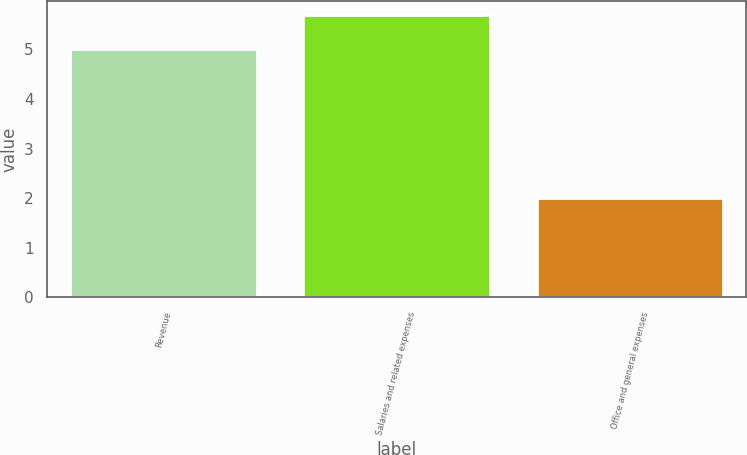Convert chart. <chart><loc_0><loc_0><loc_500><loc_500><bar_chart><fcel>Revenue<fcel>Salaries and related expenses<fcel>Office and general expenses<nl><fcel>5<fcel>5.7<fcel>2<nl></chart> 